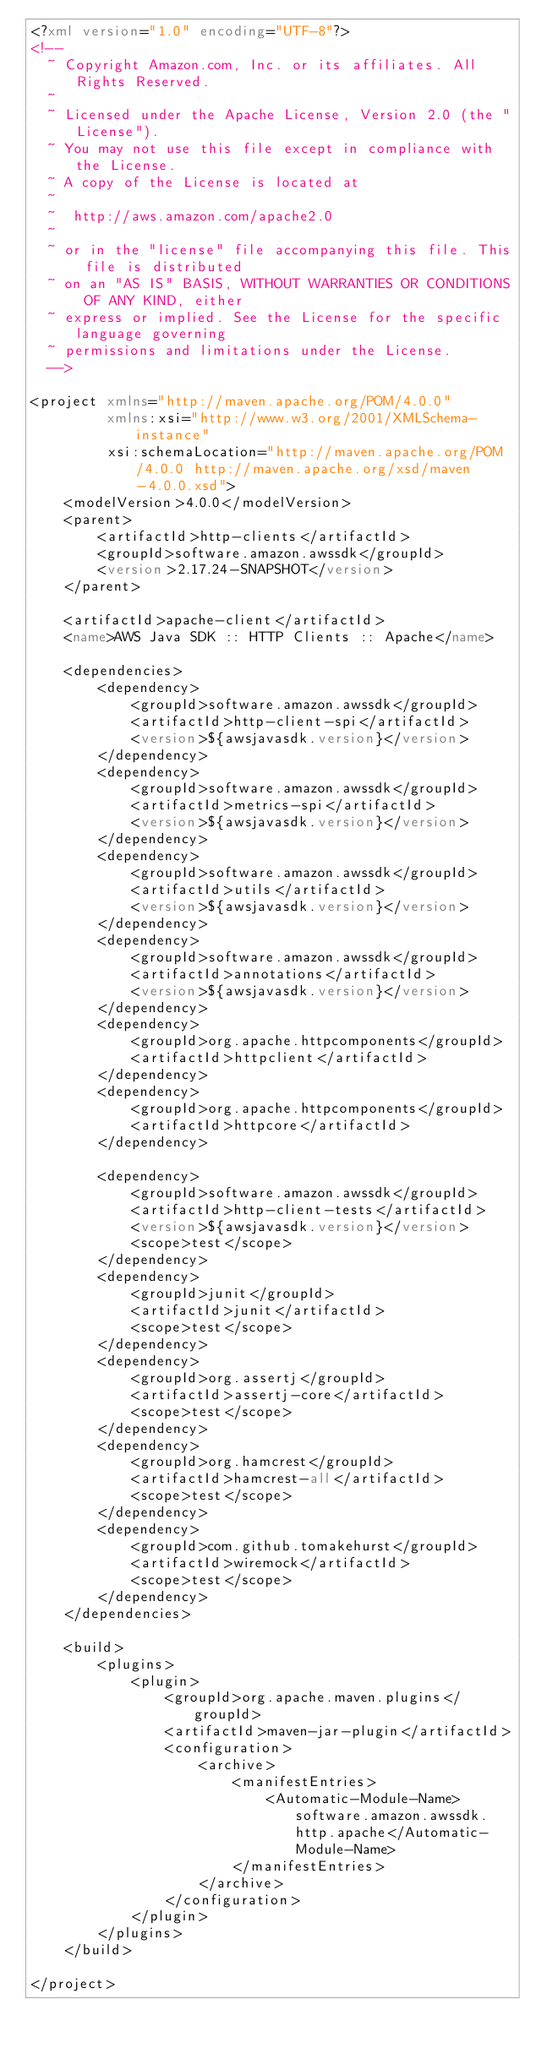<code> <loc_0><loc_0><loc_500><loc_500><_XML_><?xml version="1.0" encoding="UTF-8"?>
<!--
  ~ Copyright Amazon.com, Inc. or its affiliates. All Rights Reserved.
  ~
  ~ Licensed under the Apache License, Version 2.0 (the "License").
  ~ You may not use this file except in compliance with the License.
  ~ A copy of the License is located at
  ~
  ~  http://aws.amazon.com/apache2.0
  ~
  ~ or in the "license" file accompanying this file. This file is distributed
  ~ on an "AS IS" BASIS, WITHOUT WARRANTIES OR CONDITIONS OF ANY KIND, either
  ~ express or implied. See the License for the specific language governing
  ~ permissions and limitations under the License.
  -->

<project xmlns="http://maven.apache.org/POM/4.0.0"
         xmlns:xsi="http://www.w3.org/2001/XMLSchema-instance"
         xsi:schemaLocation="http://maven.apache.org/POM/4.0.0 http://maven.apache.org/xsd/maven-4.0.0.xsd">
    <modelVersion>4.0.0</modelVersion>
    <parent>
        <artifactId>http-clients</artifactId>
        <groupId>software.amazon.awssdk</groupId>
        <version>2.17.24-SNAPSHOT</version>
    </parent>

    <artifactId>apache-client</artifactId>
    <name>AWS Java SDK :: HTTP Clients :: Apache</name>

    <dependencies>
        <dependency>
            <groupId>software.amazon.awssdk</groupId>
            <artifactId>http-client-spi</artifactId>
            <version>${awsjavasdk.version}</version>
        </dependency>
        <dependency>
            <groupId>software.amazon.awssdk</groupId>
            <artifactId>metrics-spi</artifactId>
            <version>${awsjavasdk.version}</version>
        </dependency>
        <dependency>
            <groupId>software.amazon.awssdk</groupId>
            <artifactId>utils</artifactId>
            <version>${awsjavasdk.version}</version>
        </dependency>
        <dependency>
            <groupId>software.amazon.awssdk</groupId>
            <artifactId>annotations</artifactId>
            <version>${awsjavasdk.version}</version>
        </dependency>
        <dependency>
            <groupId>org.apache.httpcomponents</groupId>
            <artifactId>httpclient</artifactId>
        </dependency>
        <dependency>
            <groupId>org.apache.httpcomponents</groupId>
            <artifactId>httpcore</artifactId>
        </dependency>

        <dependency>
            <groupId>software.amazon.awssdk</groupId>
            <artifactId>http-client-tests</artifactId>
            <version>${awsjavasdk.version}</version>
            <scope>test</scope>
        </dependency>
        <dependency>
            <groupId>junit</groupId>
            <artifactId>junit</artifactId>
            <scope>test</scope>
        </dependency>
        <dependency>
            <groupId>org.assertj</groupId>
            <artifactId>assertj-core</artifactId>
            <scope>test</scope>
        </dependency>
        <dependency>
            <groupId>org.hamcrest</groupId>
            <artifactId>hamcrest-all</artifactId>
            <scope>test</scope>
        </dependency>
        <dependency>
            <groupId>com.github.tomakehurst</groupId>
            <artifactId>wiremock</artifactId>
            <scope>test</scope>
        </dependency>
    </dependencies>

    <build>
        <plugins>
            <plugin>
                <groupId>org.apache.maven.plugins</groupId>
                <artifactId>maven-jar-plugin</artifactId>
                <configuration>
                    <archive>
                        <manifestEntries>
                            <Automatic-Module-Name>software.amazon.awssdk.http.apache</Automatic-Module-Name>
                        </manifestEntries>
                    </archive>
                </configuration>
            </plugin>
        </plugins>
    </build>

</project>
</code> 